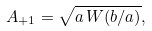Convert formula to latex. <formula><loc_0><loc_0><loc_500><loc_500>A _ { + 1 } = \sqrt { a \, W ( b / a ) } ,</formula> 